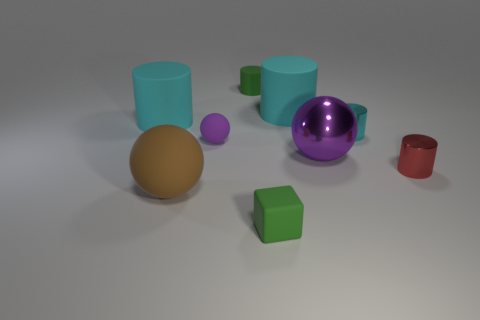How many other objects are the same size as the purple metallic sphere?
Offer a terse response. 3. What size is the red thing?
Offer a very short reply. Small. Does the brown object have the same material as the cyan thing on the right side of the large purple metal sphere?
Ensure brevity in your answer.  No. Is there a large rubber object of the same shape as the tiny red shiny object?
Your response must be concise. Yes. There is another brown ball that is the same size as the shiny sphere; what is its material?
Offer a terse response. Rubber. What size is the brown rubber ball in front of the large metallic object?
Offer a terse response. Large. Do the green object behind the matte block and the green object in front of the small green cylinder have the same size?
Make the answer very short. Yes. How many other tiny things have the same material as the small cyan thing?
Make the answer very short. 1. The tiny matte cylinder is what color?
Provide a short and direct response. Green. There is a tiny green rubber cylinder; are there any tiny matte cylinders in front of it?
Your answer should be very brief. No. 